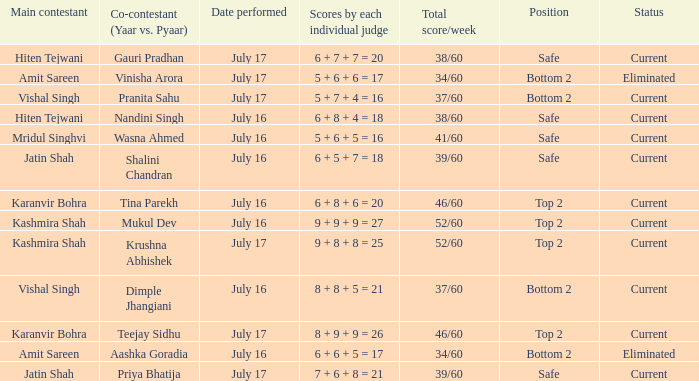What position did Pranita Sahu's team get? Bottom 2. 